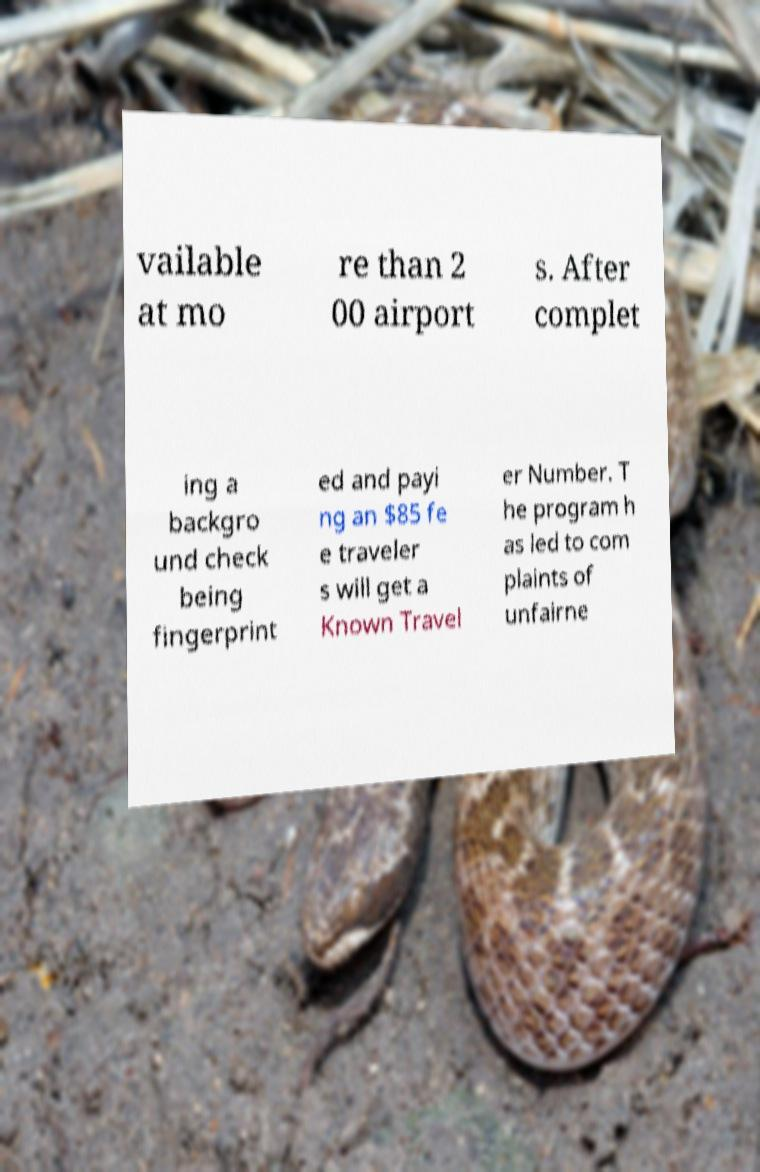Could you extract and type out the text from this image? vailable at mo re than 2 00 airport s. After complet ing a backgro und check being fingerprint ed and payi ng an $85 fe e traveler s will get a Known Travel er Number. T he program h as led to com plaints of unfairne 